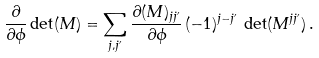<formula> <loc_0><loc_0><loc_500><loc_500>\frac { \partial } { \partial \phi } \det ( M ) = \sum _ { j , j ^ { \prime } } \frac { \partial ( M ) _ { j j ^ { \prime } } } { \partial \phi } \, ( - 1 ) ^ { j - j ^ { \prime } } \, \det ( M ^ { j j ^ { \prime } } ) \, .</formula> 